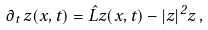Convert formula to latex. <formula><loc_0><loc_0><loc_500><loc_500>\partial _ { t } \, z ( x , t ) = \hat { L } z ( x , t ) - | z | ^ { 2 } z \, ,</formula> 